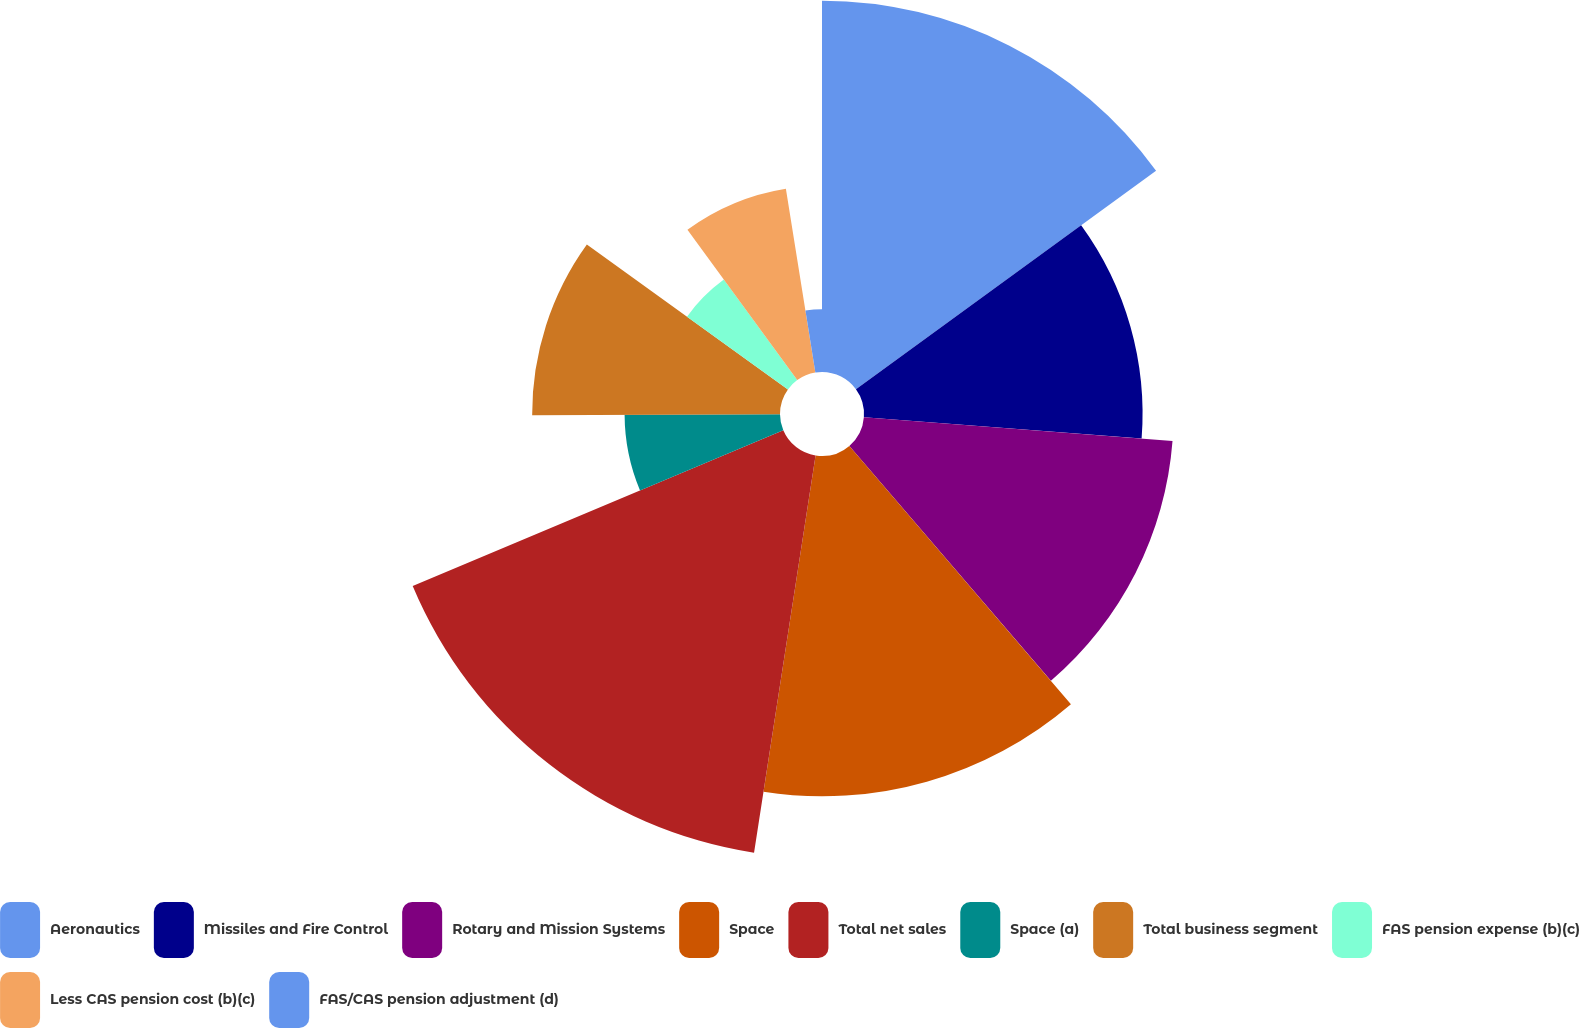<chart> <loc_0><loc_0><loc_500><loc_500><pie_chart><fcel>Aeronautics<fcel>Missiles and Fire Control<fcel>Rotary and Mission Systems<fcel>Space<fcel>Total net sales<fcel>Space (a)<fcel>Total business segment<fcel>FAS pension expense (b)(c)<fcel>Less CAS pension cost (b)(c)<fcel>FAS/CAS pension adjustment (d)<nl><fcel>14.98%<fcel>11.24%<fcel>12.49%<fcel>13.73%<fcel>16.22%<fcel>6.27%<fcel>10.0%<fcel>5.02%<fcel>7.51%<fcel>2.53%<nl></chart> 